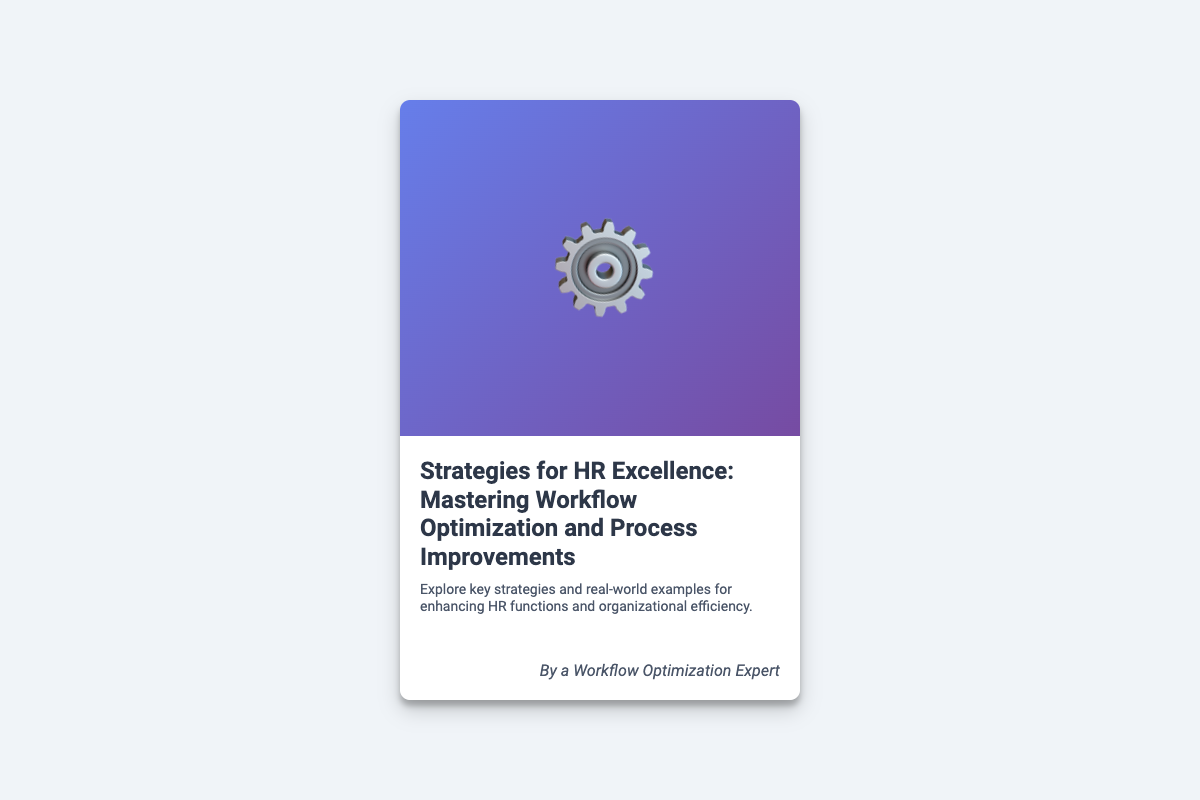What is the title of the book? The title of the book is clearly stated on the cover in a prominent font.
Answer: Strategies for HR Excellence: Mastering Workflow Optimization and Process Improvements Who is the author of the book? The author's name is mentioned at the bottom of the cover.
Answer: A Workflow Optimization Expert What is the main theme of the book? The main theme is summarized in a brief description below the title.
Answer: Enhancing HR functions and organizational efficiency What type of icon is featured on the cover? The icon symbolizes streamlined processes and is a central part of the design.
Answer: Gear What color gradient is used in the cover image? The specific color gradient is used to create an appealing visual effect.
Answer: Blue to purple What is the purpose of the book? The purpose is stated in the description under the title of the book.
Answer: Explore key strategies and real-world examples What percentage of the cover is dedicated to the cover image? The layout indicates a specific proportion of space allocated to the cover image.
Answer: 60% What design style is used for this book cover? The overall design style is characterized by a modern aesthetic.
Answer: Modern What physical feature gives the book cover an inviting look? A specific feature contributes to the overall appearance and feel of the book.
Answer: Box shadow 